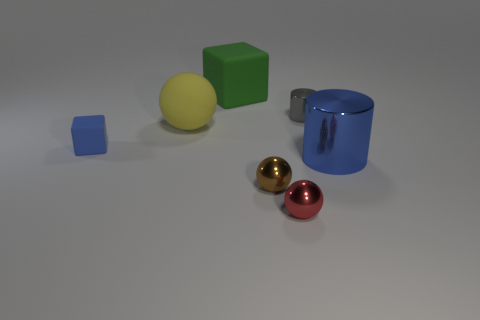Is the small matte object the same color as the large cylinder?
Your answer should be compact. Yes. How many things are either large purple cylinders or blue things that are left of the blue metallic cylinder?
Make the answer very short. 1. Is there a green matte cube that has the same size as the rubber ball?
Your response must be concise. Yes. Does the big green object have the same material as the yellow thing?
Ensure brevity in your answer.  Yes. How many objects are blue cylinders or red spheres?
Provide a succinct answer. 2. The blue metal cylinder is what size?
Your answer should be very brief. Large. Is the number of small blue rubber blocks less than the number of tiny metal objects?
Ensure brevity in your answer.  Yes. What number of small shiny things are the same color as the tiny cube?
Provide a short and direct response. 0. There is a thing left of the large yellow thing; is its color the same as the large shiny object?
Provide a succinct answer. Yes. The small thing that is in front of the small brown ball has what shape?
Make the answer very short. Sphere. 